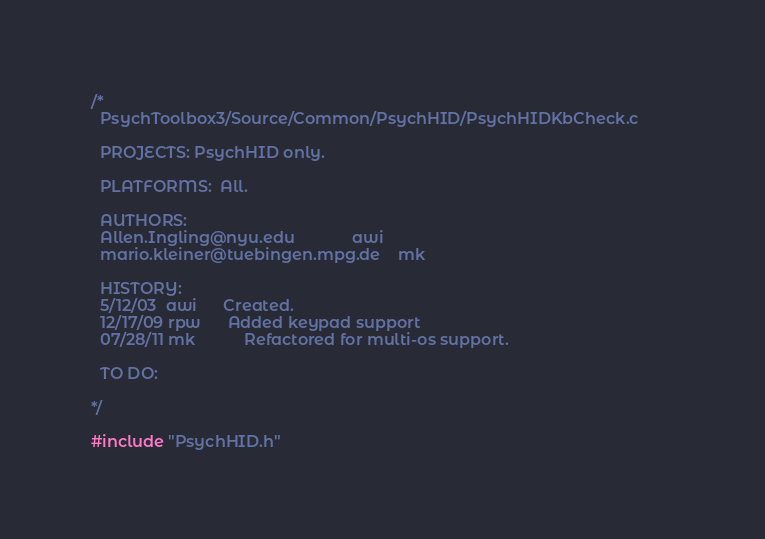Convert code to text. <code><loc_0><loc_0><loc_500><loc_500><_C_>/*
  PsychToolbox3/Source/Common/PsychHID/PsychHIDKbCheck.c		
  
  PROJECTS: PsychHID only.
  
  PLATFORMS:  All.
  
  AUTHORS:
  Allen.Ingling@nyu.edu             awi 
  mario.kleiner@tuebingen.mpg.de    mk

  HISTORY:
  5/12/03  awi		Created.
  12/17/09 rpw		Added keypad support
  07/28/11 mk           Refactored for multi-os support.
  
  TO DO:

*/

#include "PsychHID.h"
</code> 